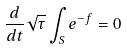<formula> <loc_0><loc_0><loc_500><loc_500>\frac { d } { d t } \sqrt { \tau } \int _ { S } e ^ { - f } = 0</formula> 